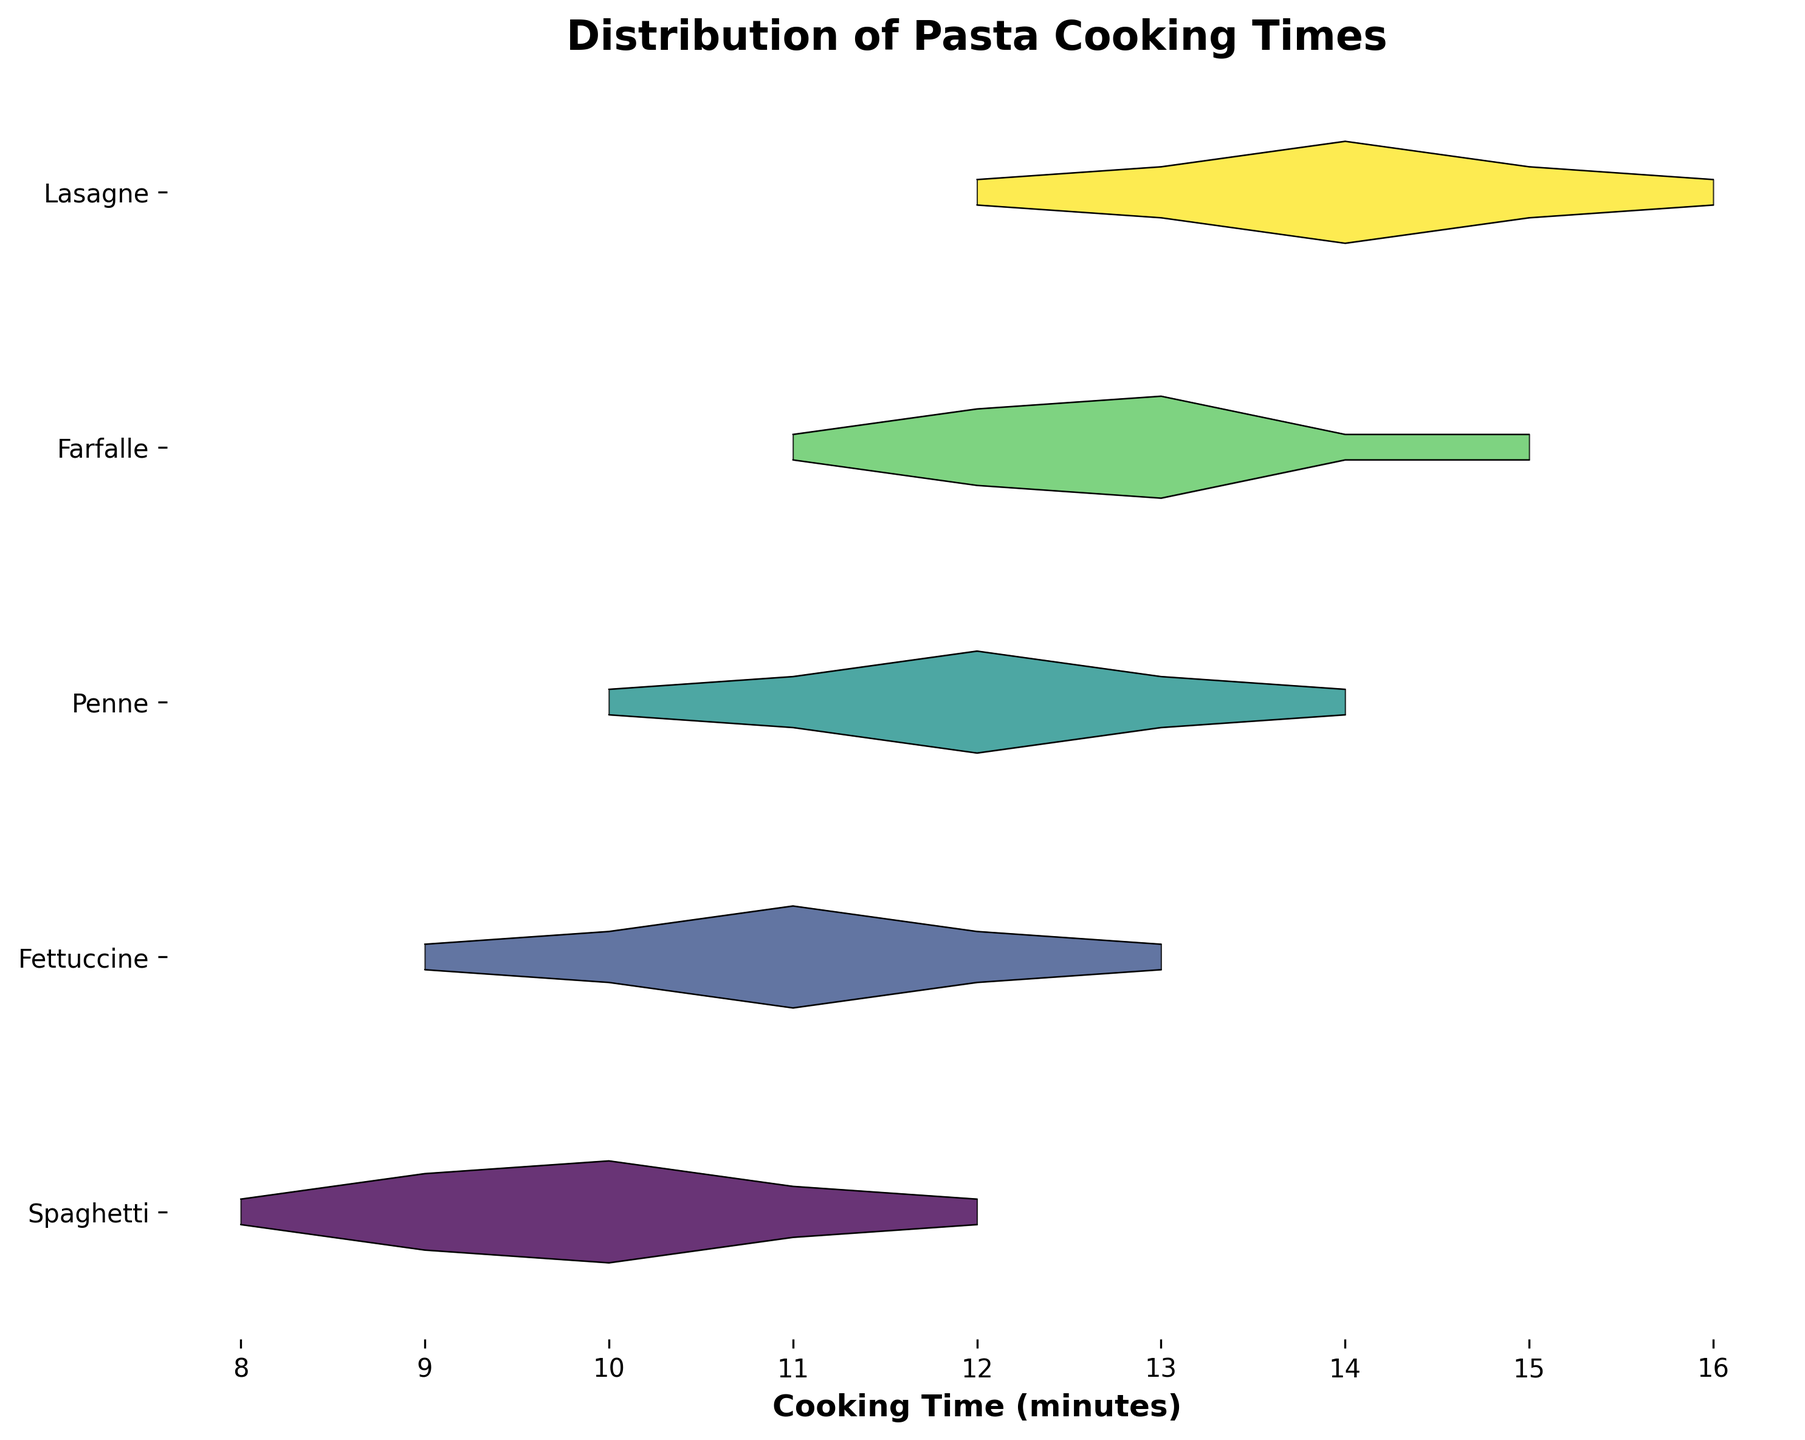What is the title of the plot? The title of the plot is displayed prominently at the top of the figure. It provides a succinct summary of the data being visualized.
Answer: Distribution of Pasta Cooking Times How many different pasta shapes are shown in the plot? By counting the unique labels on the y-axis, you can see how many different pasta shapes are represented.
Answer: 5 Which pasta shape has the highest peak density? By comparing the peaks of the density curves for each pasta shape, we can determine which one has the highest density. The highest peak represents the most frequent cooking time for that shape.
Answer: Spaghetti What is the range of cooking times for Penne? The range of a data set can be determined by identifying the minimum and maximum values on the x-axis for the specified pasta shape.
Answer: 10 to 14 minutes Which pasta shape has the longest cooking time range? By comparing the ranges of cooking times for each pasta shape, we can determine which one has the longest span from the minimum to the maximum value.
Answer: Lasagne How does the peak cooking time for Fettuccine compare to that of Farfalle? By observing the x-axis value at which the peak density occurs for both Fettuccine and Farfalle, we can compare these two values.
Answer: Fettuccine's peak is at 11 minutes, Farfalle's peak is at 13 minutes What cooking time is most common for Spaghetti? The most common cooking time corresponds to the highest point in the density curve for Spaghetti, which can be identified by finding the x-axis value at that peak.
Answer: 10 minutes Which pasta shape shows a bimodal distribution? A bimodal distribution has two distinct peaks. By examining the density curves for each pasta shape, we can identify if any shape has this characteristic.
Answer: None What is the difference in the maximum density values between Lasagne and Penne? To find this difference, we need to identify the maximum density values for both Lasagne and Penne from the y-axis and then subtract the smaller value from the larger one.
Answer: 0 Does any pasta shape have a cooking time mode shared with another? By comparing the peak(s) cooking times (the mode) for each pasta shape, we can see if any two shapes share the same value.
Answer: No, each shape has a unique mode 